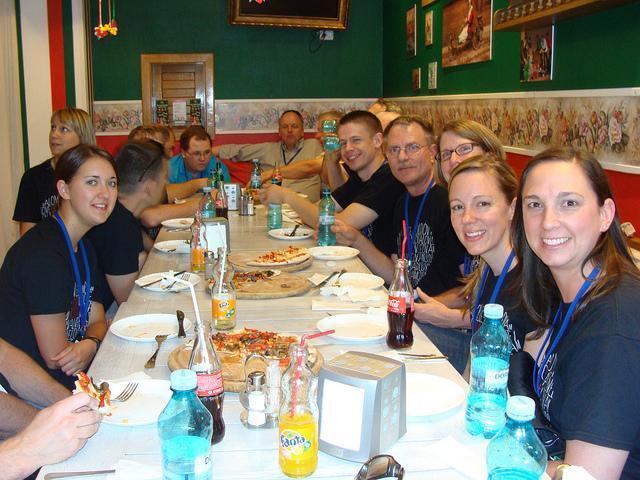How many blue bottles are on the table?
Give a very brief answer. 8. How many dining tables are visible?
Give a very brief answer. 2. How many people are there?
Give a very brief answer. 13. How many bottles are there?
Give a very brief answer. 6. How many white birds are there?
Give a very brief answer. 0. 